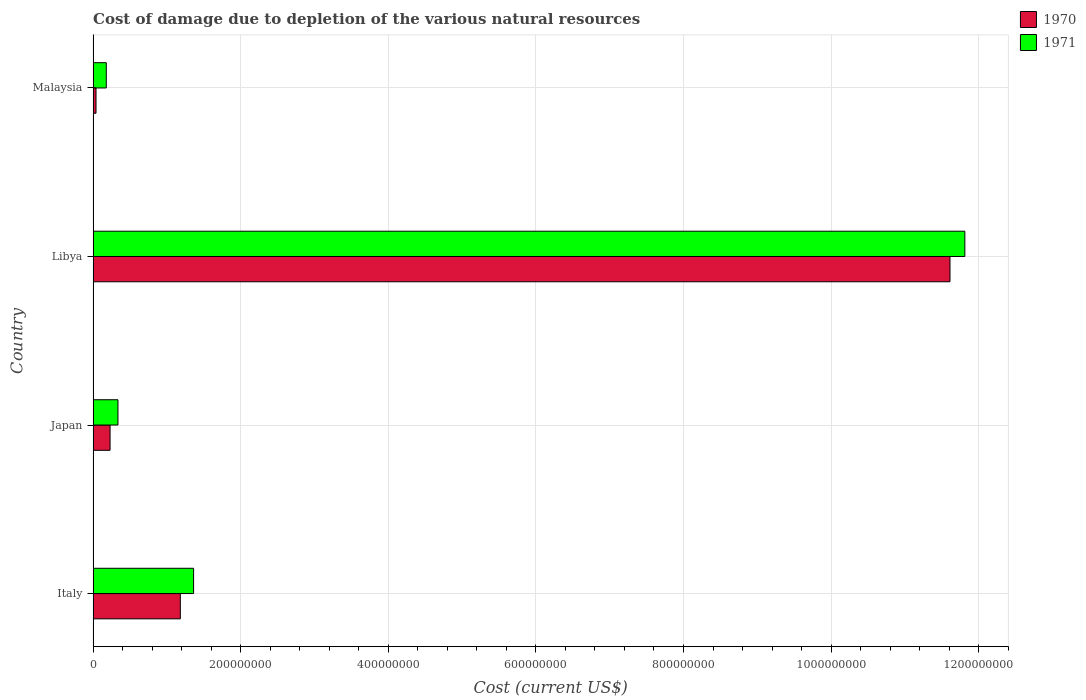How many groups of bars are there?
Offer a terse response. 4. Are the number of bars per tick equal to the number of legend labels?
Keep it short and to the point. Yes. Are the number of bars on each tick of the Y-axis equal?
Make the answer very short. Yes. How many bars are there on the 2nd tick from the bottom?
Offer a very short reply. 2. What is the label of the 3rd group of bars from the top?
Provide a short and direct response. Japan. What is the cost of damage caused due to the depletion of various natural resources in 1970 in Malaysia?
Offer a very short reply. 3.97e+06. Across all countries, what is the maximum cost of damage caused due to the depletion of various natural resources in 1970?
Ensure brevity in your answer.  1.16e+09. Across all countries, what is the minimum cost of damage caused due to the depletion of various natural resources in 1970?
Keep it short and to the point. 3.97e+06. In which country was the cost of damage caused due to the depletion of various natural resources in 1970 maximum?
Give a very brief answer. Libya. In which country was the cost of damage caused due to the depletion of various natural resources in 1970 minimum?
Give a very brief answer. Malaysia. What is the total cost of damage caused due to the depletion of various natural resources in 1971 in the graph?
Provide a short and direct response. 1.37e+09. What is the difference between the cost of damage caused due to the depletion of various natural resources in 1971 in Italy and that in Japan?
Your answer should be compact. 1.02e+08. What is the difference between the cost of damage caused due to the depletion of various natural resources in 1971 in Japan and the cost of damage caused due to the depletion of various natural resources in 1970 in Malaysia?
Your response must be concise. 2.97e+07. What is the average cost of damage caused due to the depletion of various natural resources in 1971 per country?
Make the answer very short. 3.42e+08. What is the difference between the cost of damage caused due to the depletion of various natural resources in 1971 and cost of damage caused due to the depletion of various natural resources in 1970 in Libya?
Keep it short and to the point. 2.01e+07. In how many countries, is the cost of damage caused due to the depletion of various natural resources in 1971 greater than 200000000 US$?
Keep it short and to the point. 1. What is the ratio of the cost of damage caused due to the depletion of various natural resources in 1970 in Italy to that in Japan?
Your response must be concise. 5.14. Is the cost of damage caused due to the depletion of various natural resources in 1971 in Italy less than that in Libya?
Your answer should be very brief. Yes. What is the difference between the highest and the second highest cost of damage caused due to the depletion of various natural resources in 1970?
Offer a very short reply. 1.04e+09. What is the difference between the highest and the lowest cost of damage caused due to the depletion of various natural resources in 1970?
Make the answer very short. 1.16e+09. Is the sum of the cost of damage caused due to the depletion of various natural resources in 1971 in Italy and Libya greater than the maximum cost of damage caused due to the depletion of various natural resources in 1970 across all countries?
Provide a short and direct response. Yes. What does the 2nd bar from the bottom in Japan represents?
Offer a terse response. 1971. How many bars are there?
Offer a very short reply. 8. Are all the bars in the graph horizontal?
Give a very brief answer. Yes. How many countries are there in the graph?
Give a very brief answer. 4. Are the values on the major ticks of X-axis written in scientific E-notation?
Your response must be concise. No. Does the graph contain any zero values?
Your response must be concise. No. How many legend labels are there?
Provide a short and direct response. 2. What is the title of the graph?
Ensure brevity in your answer.  Cost of damage due to depletion of the various natural resources. Does "2007" appear as one of the legend labels in the graph?
Your response must be concise. No. What is the label or title of the X-axis?
Your answer should be very brief. Cost (current US$). What is the Cost (current US$) in 1970 in Italy?
Offer a very short reply. 1.18e+08. What is the Cost (current US$) of 1971 in Italy?
Offer a very short reply. 1.36e+08. What is the Cost (current US$) in 1970 in Japan?
Make the answer very short. 2.30e+07. What is the Cost (current US$) of 1971 in Japan?
Offer a very short reply. 3.37e+07. What is the Cost (current US$) of 1970 in Libya?
Your response must be concise. 1.16e+09. What is the Cost (current US$) of 1971 in Libya?
Ensure brevity in your answer.  1.18e+09. What is the Cost (current US$) in 1970 in Malaysia?
Your response must be concise. 3.97e+06. What is the Cost (current US$) of 1971 in Malaysia?
Offer a terse response. 1.79e+07. Across all countries, what is the maximum Cost (current US$) in 1970?
Keep it short and to the point. 1.16e+09. Across all countries, what is the maximum Cost (current US$) of 1971?
Ensure brevity in your answer.  1.18e+09. Across all countries, what is the minimum Cost (current US$) in 1970?
Provide a succinct answer. 3.97e+06. Across all countries, what is the minimum Cost (current US$) in 1971?
Make the answer very short. 1.79e+07. What is the total Cost (current US$) in 1970 in the graph?
Your answer should be very brief. 1.31e+09. What is the total Cost (current US$) of 1971 in the graph?
Offer a very short reply. 1.37e+09. What is the difference between the Cost (current US$) of 1970 in Italy and that in Japan?
Offer a very short reply. 9.52e+07. What is the difference between the Cost (current US$) in 1971 in Italy and that in Japan?
Offer a very short reply. 1.02e+08. What is the difference between the Cost (current US$) in 1970 in Italy and that in Libya?
Make the answer very short. -1.04e+09. What is the difference between the Cost (current US$) in 1971 in Italy and that in Libya?
Offer a very short reply. -1.05e+09. What is the difference between the Cost (current US$) in 1970 in Italy and that in Malaysia?
Ensure brevity in your answer.  1.14e+08. What is the difference between the Cost (current US$) in 1971 in Italy and that in Malaysia?
Your answer should be compact. 1.18e+08. What is the difference between the Cost (current US$) of 1970 in Japan and that in Libya?
Offer a terse response. -1.14e+09. What is the difference between the Cost (current US$) in 1971 in Japan and that in Libya?
Offer a terse response. -1.15e+09. What is the difference between the Cost (current US$) in 1970 in Japan and that in Malaysia?
Ensure brevity in your answer.  1.90e+07. What is the difference between the Cost (current US$) in 1971 in Japan and that in Malaysia?
Offer a terse response. 1.58e+07. What is the difference between the Cost (current US$) in 1970 in Libya and that in Malaysia?
Provide a succinct answer. 1.16e+09. What is the difference between the Cost (current US$) in 1971 in Libya and that in Malaysia?
Provide a succinct answer. 1.16e+09. What is the difference between the Cost (current US$) in 1970 in Italy and the Cost (current US$) in 1971 in Japan?
Give a very brief answer. 8.45e+07. What is the difference between the Cost (current US$) of 1970 in Italy and the Cost (current US$) of 1971 in Libya?
Make the answer very short. -1.06e+09. What is the difference between the Cost (current US$) in 1970 in Italy and the Cost (current US$) in 1971 in Malaysia?
Give a very brief answer. 1.00e+08. What is the difference between the Cost (current US$) in 1970 in Japan and the Cost (current US$) in 1971 in Libya?
Make the answer very short. -1.16e+09. What is the difference between the Cost (current US$) in 1970 in Japan and the Cost (current US$) in 1971 in Malaysia?
Keep it short and to the point. 5.12e+06. What is the difference between the Cost (current US$) in 1970 in Libya and the Cost (current US$) in 1971 in Malaysia?
Your answer should be very brief. 1.14e+09. What is the average Cost (current US$) in 1970 per country?
Your answer should be compact. 3.27e+08. What is the average Cost (current US$) in 1971 per country?
Give a very brief answer. 3.42e+08. What is the difference between the Cost (current US$) in 1970 and Cost (current US$) in 1971 in Italy?
Your answer should be compact. -1.80e+07. What is the difference between the Cost (current US$) in 1970 and Cost (current US$) in 1971 in Japan?
Keep it short and to the point. -1.07e+07. What is the difference between the Cost (current US$) in 1970 and Cost (current US$) in 1971 in Libya?
Provide a short and direct response. -2.01e+07. What is the difference between the Cost (current US$) of 1970 and Cost (current US$) of 1971 in Malaysia?
Keep it short and to the point. -1.39e+07. What is the ratio of the Cost (current US$) of 1970 in Italy to that in Japan?
Your answer should be compact. 5.14. What is the ratio of the Cost (current US$) in 1971 in Italy to that in Japan?
Your answer should be very brief. 4.04. What is the ratio of the Cost (current US$) of 1970 in Italy to that in Libya?
Make the answer very short. 0.1. What is the ratio of the Cost (current US$) in 1971 in Italy to that in Libya?
Ensure brevity in your answer.  0.12. What is the ratio of the Cost (current US$) of 1970 in Italy to that in Malaysia?
Keep it short and to the point. 29.77. What is the ratio of the Cost (current US$) in 1971 in Italy to that in Malaysia?
Your answer should be very brief. 7.62. What is the ratio of the Cost (current US$) of 1970 in Japan to that in Libya?
Keep it short and to the point. 0.02. What is the ratio of the Cost (current US$) in 1971 in Japan to that in Libya?
Provide a short and direct response. 0.03. What is the ratio of the Cost (current US$) of 1970 in Japan to that in Malaysia?
Your response must be concise. 5.79. What is the ratio of the Cost (current US$) in 1971 in Japan to that in Malaysia?
Provide a short and direct response. 1.88. What is the ratio of the Cost (current US$) of 1970 in Libya to that in Malaysia?
Your answer should be very brief. 292.43. What is the ratio of the Cost (current US$) in 1971 in Libya to that in Malaysia?
Make the answer very short. 66.06. What is the difference between the highest and the second highest Cost (current US$) in 1970?
Your answer should be compact. 1.04e+09. What is the difference between the highest and the second highest Cost (current US$) in 1971?
Your response must be concise. 1.05e+09. What is the difference between the highest and the lowest Cost (current US$) in 1970?
Make the answer very short. 1.16e+09. What is the difference between the highest and the lowest Cost (current US$) of 1971?
Give a very brief answer. 1.16e+09. 